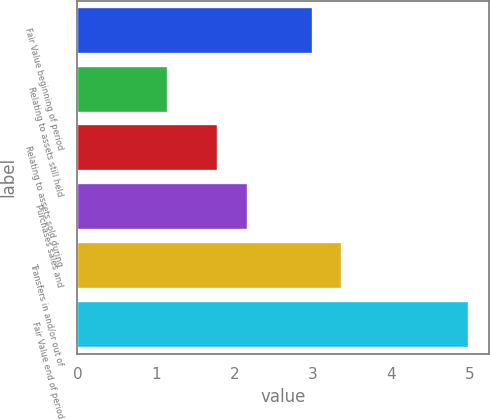Convert chart. <chart><loc_0><loc_0><loc_500><loc_500><bar_chart><fcel>Fair Value beginning of period<fcel>Relating to assets still held<fcel>Relating to assets sold during<fcel>Purchases sales and<fcel>Transfers in and/or out of<fcel>Fair Value end of period<nl><fcel>3<fcel>1.15<fcel>1.79<fcel>2.17<fcel>3.38<fcel>5<nl></chart> 